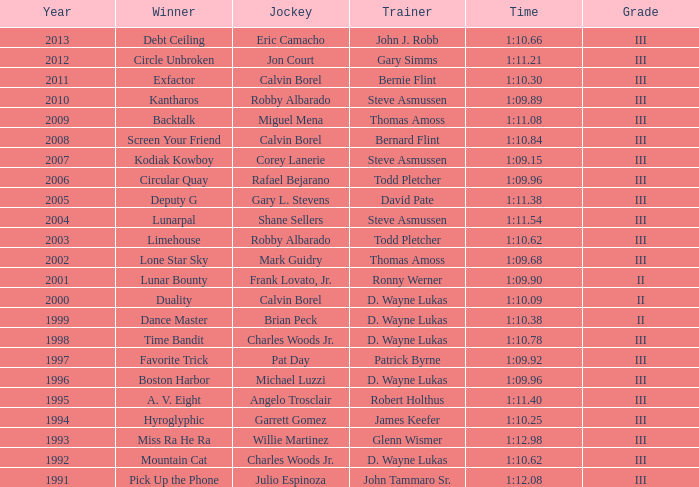Which trainer won the hyroglyphic in a year that was before 2010? James Keefer. 